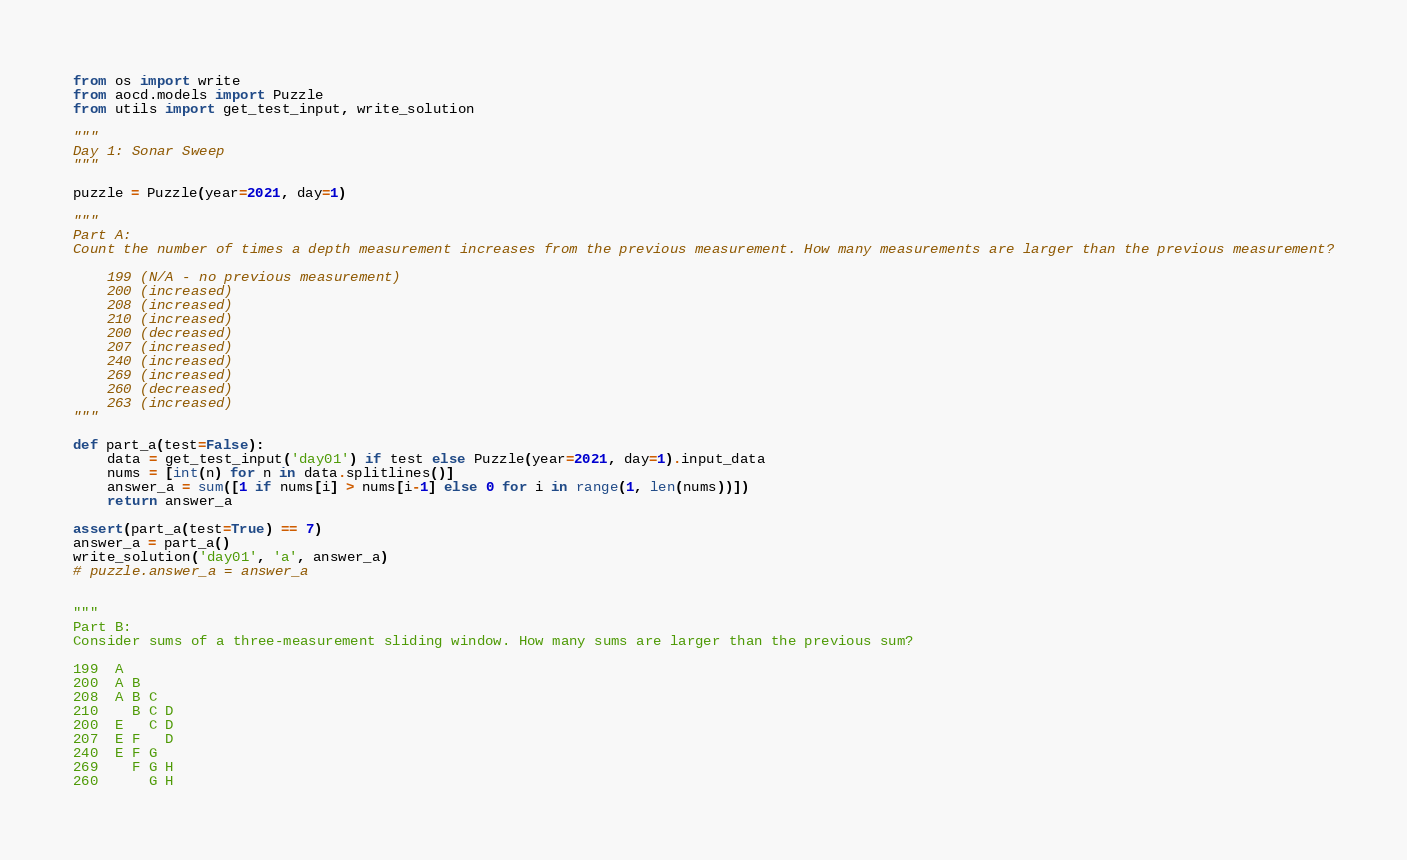<code> <loc_0><loc_0><loc_500><loc_500><_Python_>from os import write
from aocd.models import Puzzle
from utils import get_test_input, write_solution

"""
Day 1: Sonar Sweep
"""

puzzle = Puzzle(year=2021, day=1)

"""
Part A: 
Count the number of times a depth measurement increases from the previous measurement. How many measurements are larger than the previous measurement?

    199 (N/A - no previous measurement)
    200 (increased)
    208 (increased)
    210 (increased)
    200 (decreased)
    207 (increased)
    240 (increased)
    269 (increased)
    260 (decreased)
    263 (increased)
"""

def part_a(test=False):
    data = get_test_input('day01') if test else Puzzle(year=2021, day=1).input_data
    nums = [int(n) for n in data.splitlines()]
    answer_a = sum([1 if nums[i] > nums[i-1] else 0 for i in range(1, len(nums))])
    return answer_a

assert(part_a(test=True) == 7)
answer_a = part_a()
write_solution('day01', 'a', answer_a)
# puzzle.answer_a = answer_a  


"""
Part B:
Consider sums of a three-measurement sliding window. How many sums are larger than the previous sum?

199  A      
200  A B    
208  A B C  
210    B C D
200  E   C D
207  E F   D
240  E F G  
269    F G H
260      G H</code> 